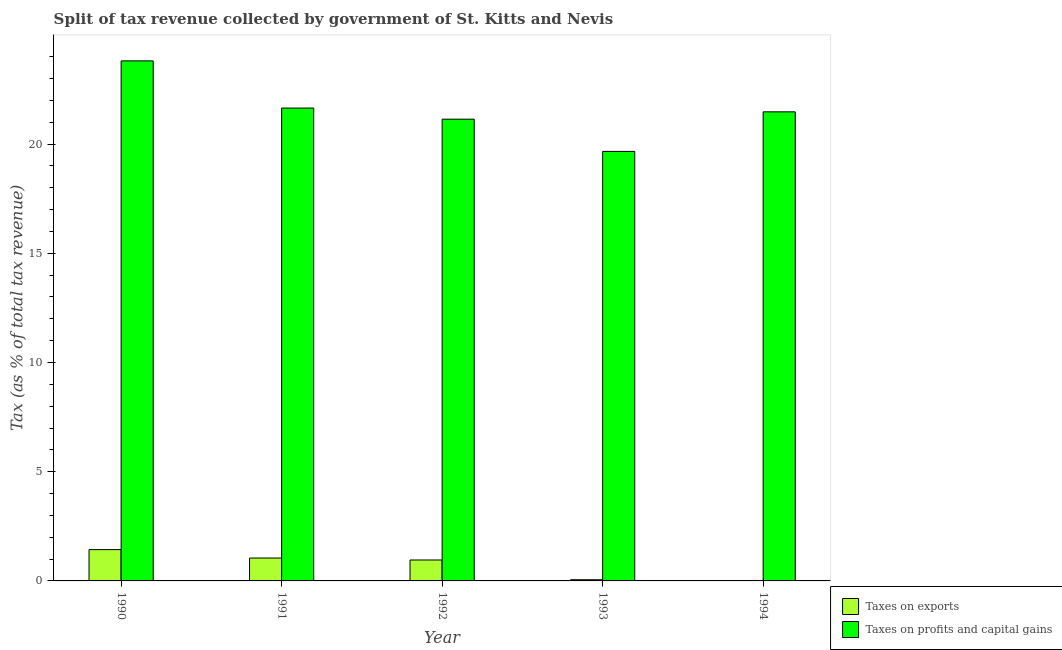How many different coloured bars are there?
Keep it short and to the point. 2. How many groups of bars are there?
Your response must be concise. 5. How many bars are there on the 5th tick from the left?
Make the answer very short. 2. What is the label of the 3rd group of bars from the left?
Provide a succinct answer. 1992. In how many cases, is the number of bars for a given year not equal to the number of legend labels?
Ensure brevity in your answer.  0. What is the percentage of revenue obtained from taxes on exports in 1993?
Your answer should be compact. 0.06. Across all years, what is the maximum percentage of revenue obtained from taxes on exports?
Offer a very short reply. 1.43. Across all years, what is the minimum percentage of revenue obtained from taxes on profits and capital gains?
Your response must be concise. 19.66. What is the total percentage of revenue obtained from taxes on exports in the graph?
Ensure brevity in your answer.  3.5. What is the difference between the percentage of revenue obtained from taxes on profits and capital gains in 1990 and that in 1992?
Provide a succinct answer. 2.67. What is the difference between the percentage of revenue obtained from taxes on profits and capital gains in 1991 and the percentage of revenue obtained from taxes on exports in 1993?
Offer a very short reply. 1.98. What is the average percentage of revenue obtained from taxes on exports per year?
Ensure brevity in your answer.  0.7. What is the ratio of the percentage of revenue obtained from taxes on profits and capital gains in 1992 to that in 1993?
Offer a terse response. 1.08. What is the difference between the highest and the second highest percentage of revenue obtained from taxes on exports?
Ensure brevity in your answer.  0.39. What is the difference between the highest and the lowest percentage of revenue obtained from taxes on profits and capital gains?
Give a very brief answer. 4.14. In how many years, is the percentage of revenue obtained from taxes on exports greater than the average percentage of revenue obtained from taxes on exports taken over all years?
Provide a short and direct response. 3. Is the sum of the percentage of revenue obtained from taxes on exports in 1992 and 1993 greater than the maximum percentage of revenue obtained from taxes on profits and capital gains across all years?
Provide a short and direct response. No. What does the 2nd bar from the left in 1991 represents?
Your answer should be compact. Taxes on profits and capital gains. What does the 1st bar from the right in 1994 represents?
Your response must be concise. Taxes on profits and capital gains. How many years are there in the graph?
Your answer should be very brief. 5. What is the difference between two consecutive major ticks on the Y-axis?
Provide a short and direct response. 5. Are the values on the major ticks of Y-axis written in scientific E-notation?
Offer a very short reply. No. Does the graph contain grids?
Keep it short and to the point. No. How many legend labels are there?
Your response must be concise. 2. What is the title of the graph?
Give a very brief answer. Split of tax revenue collected by government of St. Kitts and Nevis. Does "Secondary education" appear as one of the legend labels in the graph?
Your answer should be very brief. No. What is the label or title of the Y-axis?
Provide a short and direct response. Tax (as % of total tax revenue). What is the Tax (as % of total tax revenue) in Taxes on exports in 1990?
Offer a very short reply. 1.43. What is the Tax (as % of total tax revenue) of Taxes on profits and capital gains in 1990?
Offer a terse response. 23.81. What is the Tax (as % of total tax revenue) of Taxes on exports in 1991?
Offer a terse response. 1.05. What is the Tax (as % of total tax revenue) in Taxes on profits and capital gains in 1991?
Make the answer very short. 21.65. What is the Tax (as % of total tax revenue) in Taxes on exports in 1992?
Your answer should be compact. 0.96. What is the Tax (as % of total tax revenue) in Taxes on profits and capital gains in 1992?
Your answer should be compact. 21.14. What is the Tax (as % of total tax revenue) in Taxes on exports in 1993?
Provide a short and direct response. 0.06. What is the Tax (as % of total tax revenue) of Taxes on profits and capital gains in 1993?
Offer a terse response. 19.66. What is the Tax (as % of total tax revenue) of Taxes on exports in 1994?
Make the answer very short. 0.01. What is the Tax (as % of total tax revenue) of Taxes on profits and capital gains in 1994?
Your answer should be compact. 21.47. Across all years, what is the maximum Tax (as % of total tax revenue) of Taxes on exports?
Provide a succinct answer. 1.43. Across all years, what is the maximum Tax (as % of total tax revenue) in Taxes on profits and capital gains?
Offer a terse response. 23.81. Across all years, what is the minimum Tax (as % of total tax revenue) in Taxes on exports?
Your answer should be compact. 0.01. Across all years, what is the minimum Tax (as % of total tax revenue) in Taxes on profits and capital gains?
Your answer should be compact. 19.66. What is the total Tax (as % of total tax revenue) of Taxes on exports in the graph?
Offer a very short reply. 3.5. What is the total Tax (as % of total tax revenue) in Taxes on profits and capital gains in the graph?
Provide a succinct answer. 107.73. What is the difference between the Tax (as % of total tax revenue) in Taxes on exports in 1990 and that in 1991?
Your answer should be very brief. 0.39. What is the difference between the Tax (as % of total tax revenue) in Taxes on profits and capital gains in 1990 and that in 1991?
Make the answer very short. 2.16. What is the difference between the Tax (as % of total tax revenue) in Taxes on exports in 1990 and that in 1992?
Give a very brief answer. 0.48. What is the difference between the Tax (as % of total tax revenue) in Taxes on profits and capital gains in 1990 and that in 1992?
Your answer should be compact. 2.67. What is the difference between the Tax (as % of total tax revenue) in Taxes on exports in 1990 and that in 1993?
Your response must be concise. 1.38. What is the difference between the Tax (as % of total tax revenue) in Taxes on profits and capital gains in 1990 and that in 1993?
Ensure brevity in your answer.  4.14. What is the difference between the Tax (as % of total tax revenue) in Taxes on exports in 1990 and that in 1994?
Your answer should be compact. 1.43. What is the difference between the Tax (as % of total tax revenue) in Taxes on profits and capital gains in 1990 and that in 1994?
Your answer should be compact. 2.33. What is the difference between the Tax (as % of total tax revenue) of Taxes on exports in 1991 and that in 1992?
Your answer should be compact. 0.09. What is the difference between the Tax (as % of total tax revenue) in Taxes on profits and capital gains in 1991 and that in 1992?
Your response must be concise. 0.51. What is the difference between the Tax (as % of total tax revenue) in Taxes on profits and capital gains in 1991 and that in 1993?
Your response must be concise. 1.98. What is the difference between the Tax (as % of total tax revenue) of Taxes on exports in 1991 and that in 1994?
Give a very brief answer. 1.04. What is the difference between the Tax (as % of total tax revenue) in Taxes on profits and capital gains in 1991 and that in 1994?
Offer a very short reply. 0.17. What is the difference between the Tax (as % of total tax revenue) in Taxes on exports in 1992 and that in 1993?
Your response must be concise. 0.9. What is the difference between the Tax (as % of total tax revenue) of Taxes on profits and capital gains in 1992 and that in 1993?
Provide a short and direct response. 1.48. What is the difference between the Tax (as % of total tax revenue) of Taxes on exports in 1992 and that in 1994?
Keep it short and to the point. 0.95. What is the difference between the Tax (as % of total tax revenue) of Taxes on profits and capital gains in 1992 and that in 1994?
Provide a succinct answer. -0.34. What is the difference between the Tax (as % of total tax revenue) of Taxes on exports in 1993 and that in 1994?
Your response must be concise. 0.05. What is the difference between the Tax (as % of total tax revenue) in Taxes on profits and capital gains in 1993 and that in 1994?
Your answer should be very brief. -1.81. What is the difference between the Tax (as % of total tax revenue) in Taxes on exports in 1990 and the Tax (as % of total tax revenue) in Taxes on profits and capital gains in 1991?
Your answer should be compact. -20.21. What is the difference between the Tax (as % of total tax revenue) of Taxes on exports in 1990 and the Tax (as % of total tax revenue) of Taxes on profits and capital gains in 1992?
Provide a succinct answer. -19.7. What is the difference between the Tax (as % of total tax revenue) in Taxes on exports in 1990 and the Tax (as % of total tax revenue) in Taxes on profits and capital gains in 1993?
Keep it short and to the point. -18.23. What is the difference between the Tax (as % of total tax revenue) of Taxes on exports in 1990 and the Tax (as % of total tax revenue) of Taxes on profits and capital gains in 1994?
Provide a short and direct response. -20.04. What is the difference between the Tax (as % of total tax revenue) in Taxes on exports in 1991 and the Tax (as % of total tax revenue) in Taxes on profits and capital gains in 1992?
Your answer should be compact. -20.09. What is the difference between the Tax (as % of total tax revenue) of Taxes on exports in 1991 and the Tax (as % of total tax revenue) of Taxes on profits and capital gains in 1993?
Provide a succinct answer. -18.61. What is the difference between the Tax (as % of total tax revenue) in Taxes on exports in 1991 and the Tax (as % of total tax revenue) in Taxes on profits and capital gains in 1994?
Your answer should be very brief. -20.43. What is the difference between the Tax (as % of total tax revenue) of Taxes on exports in 1992 and the Tax (as % of total tax revenue) of Taxes on profits and capital gains in 1993?
Provide a succinct answer. -18.7. What is the difference between the Tax (as % of total tax revenue) in Taxes on exports in 1992 and the Tax (as % of total tax revenue) in Taxes on profits and capital gains in 1994?
Your answer should be very brief. -20.51. What is the difference between the Tax (as % of total tax revenue) in Taxes on exports in 1993 and the Tax (as % of total tax revenue) in Taxes on profits and capital gains in 1994?
Offer a very short reply. -21.42. What is the average Tax (as % of total tax revenue) in Taxes on exports per year?
Give a very brief answer. 0.7. What is the average Tax (as % of total tax revenue) in Taxes on profits and capital gains per year?
Give a very brief answer. 21.55. In the year 1990, what is the difference between the Tax (as % of total tax revenue) of Taxes on exports and Tax (as % of total tax revenue) of Taxes on profits and capital gains?
Ensure brevity in your answer.  -22.37. In the year 1991, what is the difference between the Tax (as % of total tax revenue) of Taxes on exports and Tax (as % of total tax revenue) of Taxes on profits and capital gains?
Give a very brief answer. -20.6. In the year 1992, what is the difference between the Tax (as % of total tax revenue) of Taxes on exports and Tax (as % of total tax revenue) of Taxes on profits and capital gains?
Give a very brief answer. -20.18. In the year 1993, what is the difference between the Tax (as % of total tax revenue) in Taxes on exports and Tax (as % of total tax revenue) in Taxes on profits and capital gains?
Your answer should be compact. -19.61. In the year 1994, what is the difference between the Tax (as % of total tax revenue) of Taxes on exports and Tax (as % of total tax revenue) of Taxes on profits and capital gains?
Your response must be concise. -21.46. What is the ratio of the Tax (as % of total tax revenue) of Taxes on exports in 1990 to that in 1991?
Make the answer very short. 1.37. What is the ratio of the Tax (as % of total tax revenue) in Taxes on profits and capital gains in 1990 to that in 1991?
Keep it short and to the point. 1.1. What is the ratio of the Tax (as % of total tax revenue) of Taxes on exports in 1990 to that in 1992?
Your response must be concise. 1.5. What is the ratio of the Tax (as % of total tax revenue) in Taxes on profits and capital gains in 1990 to that in 1992?
Provide a short and direct response. 1.13. What is the ratio of the Tax (as % of total tax revenue) of Taxes on exports in 1990 to that in 1993?
Your answer should be very brief. 25.86. What is the ratio of the Tax (as % of total tax revenue) in Taxes on profits and capital gains in 1990 to that in 1993?
Provide a succinct answer. 1.21. What is the ratio of the Tax (as % of total tax revenue) of Taxes on exports in 1990 to that in 1994?
Make the answer very short. 174.21. What is the ratio of the Tax (as % of total tax revenue) of Taxes on profits and capital gains in 1990 to that in 1994?
Make the answer very short. 1.11. What is the ratio of the Tax (as % of total tax revenue) in Taxes on exports in 1991 to that in 1992?
Your answer should be compact. 1.09. What is the ratio of the Tax (as % of total tax revenue) of Taxes on profits and capital gains in 1991 to that in 1992?
Keep it short and to the point. 1.02. What is the ratio of the Tax (as % of total tax revenue) in Taxes on exports in 1991 to that in 1993?
Offer a very short reply. 18.9. What is the ratio of the Tax (as % of total tax revenue) in Taxes on profits and capital gains in 1991 to that in 1993?
Provide a succinct answer. 1.1. What is the ratio of the Tax (as % of total tax revenue) of Taxes on exports in 1991 to that in 1994?
Offer a very short reply. 127.31. What is the ratio of the Tax (as % of total tax revenue) in Taxes on profits and capital gains in 1991 to that in 1994?
Offer a terse response. 1.01. What is the ratio of the Tax (as % of total tax revenue) in Taxes on exports in 1992 to that in 1993?
Offer a terse response. 17.29. What is the ratio of the Tax (as % of total tax revenue) in Taxes on profits and capital gains in 1992 to that in 1993?
Give a very brief answer. 1.07. What is the ratio of the Tax (as % of total tax revenue) in Taxes on exports in 1992 to that in 1994?
Provide a succinct answer. 116.45. What is the ratio of the Tax (as % of total tax revenue) in Taxes on profits and capital gains in 1992 to that in 1994?
Make the answer very short. 0.98. What is the ratio of the Tax (as % of total tax revenue) in Taxes on exports in 1993 to that in 1994?
Offer a very short reply. 6.74. What is the ratio of the Tax (as % of total tax revenue) of Taxes on profits and capital gains in 1993 to that in 1994?
Your answer should be compact. 0.92. What is the difference between the highest and the second highest Tax (as % of total tax revenue) in Taxes on exports?
Your answer should be very brief. 0.39. What is the difference between the highest and the second highest Tax (as % of total tax revenue) of Taxes on profits and capital gains?
Make the answer very short. 2.16. What is the difference between the highest and the lowest Tax (as % of total tax revenue) of Taxes on exports?
Keep it short and to the point. 1.43. What is the difference between the highest and the lowest Tax (as % of total tax revenue) in Taxes on profits and capital gains?
Offer a terse response. 4.14. 